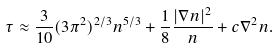Convert formula to latex. <formula><loc_0><loc_0><loc_500><loc_500>\tau \approx \frac { 3 } { 1 0 } ( 3 \pi ^ { 2 } ) ^ { 2 / 3 } n ^ { 5 / 3 } + \frac { 1 } { 8 } \frac { | \nabla n | ^ { 2 } } { n } + c \nabla ^ { 2 } n .</formula> 